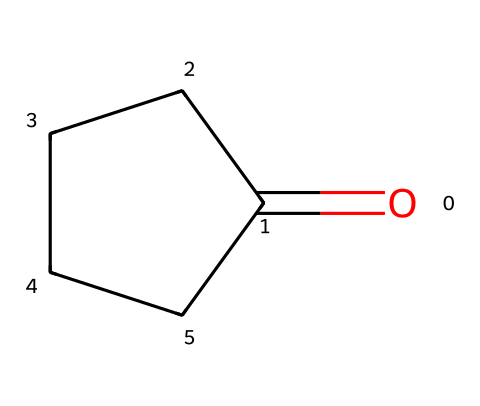What is the main functional group present in cyclopentanone? The structure contains a carbonyl group (C=O) which classifies it as a ketone. This can be identified from the presence of the oxygen double-bonded to the carbon within a cyclopentane ring.
Answer: carbonyl group How many carbon atoms are in cyclopentanone? The structure has five carbon atoms arranged in a ring. This can be determined by counting the 'C' symbols represented in the structure along with the carbon in the carbonyl group.
Answer: five What is the molecular formula of cyclopentanone? To determine the molecular formula, count the carbon (C), hydrogen (H), and oxygen (O) atoms in the structure: 5 carbons, 8 hydrogens, and 1 oxygen, resulting in C5H8O.
Answer: C5H8O Is cyclopentanone a cycloalkane? Cyclopentanone features a cyclic structure, but because it contains a carbonyl functional group, it is classified as a cyclic ketone rather than a purely cycloalkane.
Answer: no What type of isomerism can cyclopentanone exhibit? Because cyclopentanone can have different structural or spatial arrangements of atoms, it can exhibit structural isomerism with other ketones or stereoisomerism depending on the substituents, though primarily structural due to its ring structure.
Answer: structural isomerism What is the one characteristic that differentiates cyclopentanone from cyclopentane? The presence of a carbonyl group (C=O) distinguishes cyclopentanone from cyclopentane, which has only carbon and hydrogen atoms in a cyclic arrangement without any functional groups.
Answer: carbonyl group 